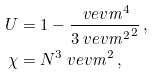<formula> <loc_0><loc_0><loc_500><loc_500>U & = 1 - \frac { \ v e v { \mathit m ^ { 4 } } } { 3 \ v e v { \mathit m ^ { 2 } } ^ { 2 } } \, , \\ \chi & = N ^ { 3 } \ v e v { \mathit m ^ { 2 } } \, ,</formula> 